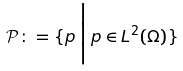<formula> <loc_0><loc_0><loc_500><loc_500>\mathcal { P } \colon = \{ p \, \Big | \, p \in L ^ { 2 } ( \Omega ) \}</formula> 